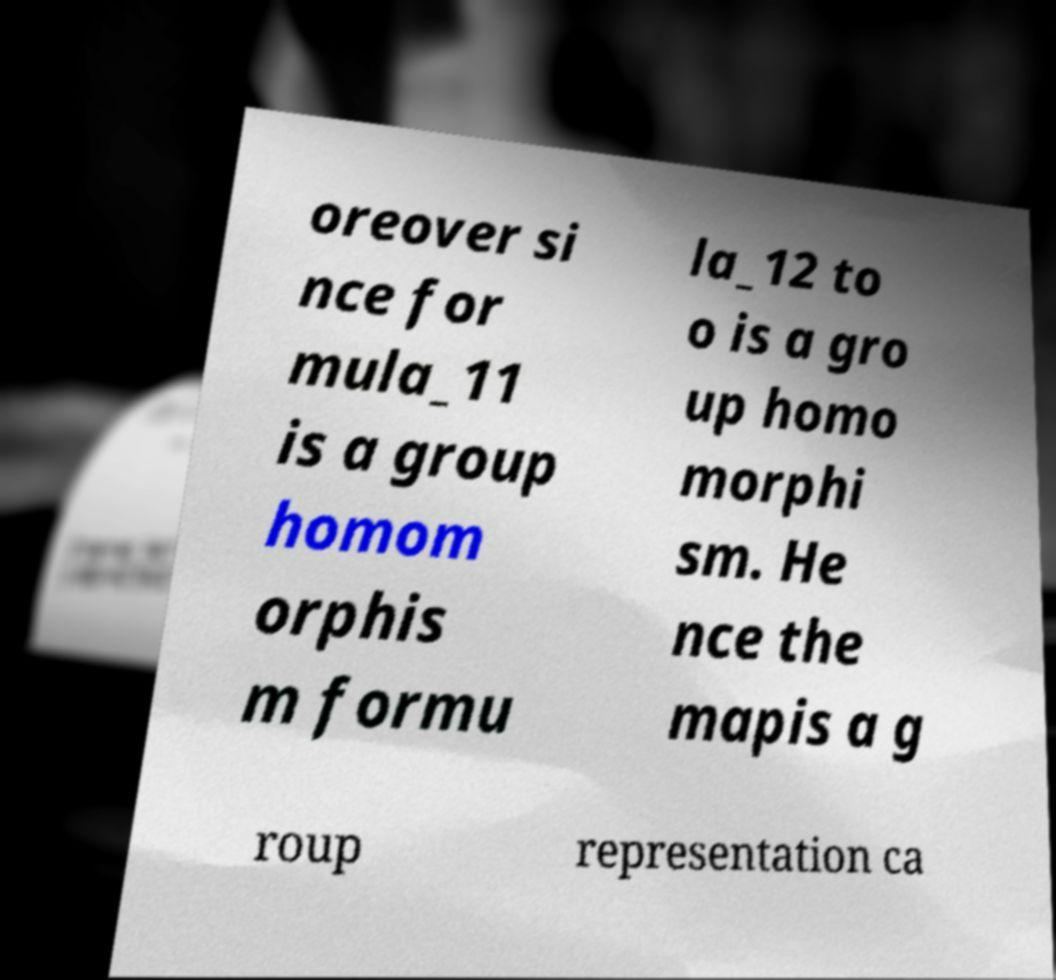What messages or text are displayed in this image? I need them in a readable, typed format. oreover si nce for mula_11 is a group homom orphis m formu la_12 to o is a gro up homo morphi sm. He nce the mapis a g roup representation ca 